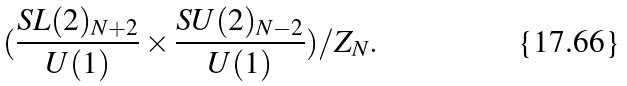<formula> <loc_0><loc_0><loc_500><loc_500>( \frac { S L ( 2 ) _ { N + 2 } } { U ( 1 ) } \times \frac { S U ( 2 ) _ { N - 2 } } { U ( 1 ) } ) / Z _ { N } .</formula> 